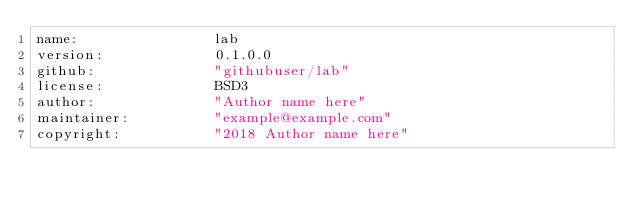<code> <loc_0><loc_0><loc_500><loc_500><_YAML_>name:                lab
version:             0.1.0.0
github:              "githubuser/lab"
license:             BSD3
author:              "Author name here"
maintainer:          "example@example.com"
copyright:           "2018 Author name here"
</code> 